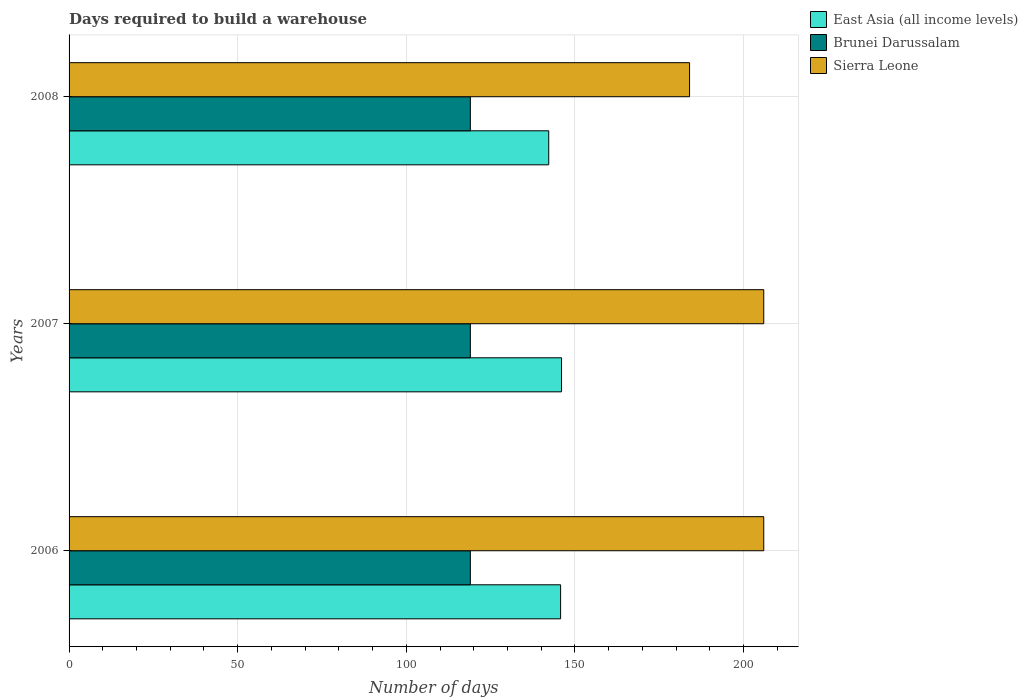How many different coloured bars are there?
Provide a succinct answer. 3. How many groups of bars are there?
Provide a succinct answer. 3. How many bars are there on the 2nd tick from the bottom?
Keep it short and to the point. 3. What is the label of the 2nd group of bars from the top?
Your answer should be compact. 2007. What is the days required to build a warehouse in in East Asia (all income levels) in 2006?
Keep it short and to the point. 145.76. Across all years, what is the maximum days required to build a warehouse in in East Asia (all income levels)?
Give a very brief answer. 146.04. Across all years, what is the minimum days required to build a warehouse in in Brunei Darussalam?
Provide a succinct answer. 119. What is the total days required to build a warehouse in in Sierra Leone in the graph?
Your response must be concise. 596. What is the difference between the days required to build a warehouse in in East Asia (all income levels) in 2006 and that in 2007?
Your answer should be compact. -0.28. What is the difference between the days required to build a warehouse in in Brunei Darussalam in 2006 and the days required to build a warehouse in in East Asia (all income levels) in 2008?
Your response must be concise. -23.24. What is the average days required to build a warehouse in in East Asia (all income levels) per year?
Keep it short and to the point. 144.68. In the year 2007, what is the difference between the days required to build a warehouse in in East Asia (all income levels) and days required to build a warehouse in in Brunei Darussalam?
Provide a short and direct response. 27.04. In how many years, is the days required to build a warehouse in in East Asia (all income levels) greater than 140 days?
Give a very brief answer. 3. What is the ratio of the days required to build a warehouse in in East Asia (all income levels) in 2006 to that in 2007?
Your answer should be very brief. 1. Is the days required to build a warehouse in in East Asia (all income levels) in 2006 less than that in 2007?
Ensure brevity in your answer.  Yes. Is the difference between the days required to build a warehouse in in East Asia (all income levels) in 2006 and 2008 greater than the difference between the days required to build a warehouse in in Brunei Darussalam in 2006 and 2008?
Your answer should be very brief. Yes. What is the difference between the highest and the lowest days required to build a warehouse in in Sierra Leone?
Your response must be concise. 22. Is the sum of the days required to build a warehouse in in Brunei Darussalam in 2006 and 2008 greater than the maximum days required to build a warehouse in in Sierra Leone across all years?
Keep it short and to the point. Yes. What does the 3rd bar from the top in 2006 represents?
Provide a short and direct response. East Asia (all income levels). What does the 2nd bar from the bottom in 2006 represents?
Make the answer very short. Brunei Darussalam. How many bars are there?
Provide a short and direct response. 9. Does the graph contain any zero values?
Provide a succinct answer. No. How many legend labels are there?
Your answer should be very brief. 3. How are the legend labels stacked?
Provide a succinct answer. Vertical. What is the title of the graph?
Make the answer very short. Days required to build a warehouse. Does "Afghanistan" appear as one of the legend labels in the graph?
Provide a succinct answer. No. What is the label or title of the X-axis?
Provide a short and direct response. Number of days. What is the Number of days in East Asia (all income levels) in 2006?
Ensure brevity in your answer.  145.76. What is the Number of days in Brunei Darussalam in 2006?
Offer a terse response. 119. What is the Number of days of Sierra Leone in 2006?
Your answer should be very brief. 206. What is the Number of days of East Asia (all income levels) in 2007?
Make the answer very short. 146.04. What is the Number of days in Brunei Darussalam in 2007?
Provide a succinct answer. 119. What is the Number of days of Sierra Leone in 2007?
Give a very brief answer. 206. What is the Number of days of East Asia (all income levels) in 2008?
Provide a short and direct response. 142.24. What is the Number of days in Brunei Darussalam in 2008?
Ensure brevity in your answer.  119. What is the Number of days in Sierra Leone in 2008?
Provide a succinct answer. 184. Across all years, what is the maximum Number of days in East Asia (all income levels)?
Provide a short and direct response. 146.04. Across all years, what is the maximum Number of days in Brunei Darussalam?
Your answer should be compact. 119. Across all years, what is the maximum Number of days in Sierra Leone?
Provide a short and direct response. 206. Across all years, what is the minimum Number of days in East Asia (all income levels)?
Keep it short and to the point. 142.24. Across all years, what is the minimum Number of days in Brunei Darussalam?
Ensure brevity in your answer.  119. Across all years, what is the minimum Number of days of Sierra Leone?
Your response must be concise. 184. What is the total Number of days of East Asia (all income levels) in the graph?
Ensure brevity in your answer.  434.04. What is the total Number of days in Brunei Darussalam in the graph?
Ensure brevity in your answer.  357. What is the total Number of days in Sierra Leone in the graph?
Provide a short and direct response. 596. What is the difference between the Number of days of East Asia (all income levels) in 2006 and that in 2007?
Provide a short and direct response. -0.28. What is the difference between the Number of days of Brunei Darussalam in 2006 and that in 2007?
Your response must be concise. 0. What is the difference between the Number of days of East Asia (all income levels) in 2006 and that in 2008?
Offer a very short reply. 3.52. What is the difference between the Number of days of Sierra Leone in 2006 and that in 2008?
Keep it short and to the point. 22. What is the difference between the Number of days of East Asia (all income levels) in 2007 and that in 2008?
Ensure brevity in your answer.  3.8. What is the difference between the Number of days in Sierra Leone in 2007 and that in 2008?
Provide a short and direct response. 22. What is the difference between the Number of days in East Asia (all income levels) in 2006 and the Number of days in Brunei Darussalam in 2007?
Keep it short and to the point. 26.76. What is the difference between the Number of days in East Asia (all income levels) in 2006 and the Number of days in Sierra Leone in 2007?
Ensure brevity in your answer.  -60.24. What is the difference between the Number of days of Brunei Darussalam in 2006 and the Number of days of Sierra Leone in 2007?
Offer a very short reply. -87. What is the difference between the Number of days of East Asia (all income levels) in 2006 and the Number of days of Brunei Darussalam in 2008?
Your answer should be compact. 26.76. What is the difference between the Number of days in East Asia (all income levels) in 2006 and the Number of days in Sierra Leone in 2008?
Your answer should be very brief. -38.24. What is the difference between the Number of days in Brunei Darussalam in 2006 and the Number of days in Sierra Leone in 2008?
Ensure brevity in your answer.  -65. What is the difference between the Number of days in East Asia (all income levels) in 2007 and the Number of days in Brunei Darussalam in 2008?
Offer a terse response. 27.04. What is the difference between the Number of days of East Asia (all income levels) in 2007 and the Number of days of Sierra Leone in 2008?
Offer a terse response. -37.96. What is the difference between the Number of days of Brunei Darussalam in 2007 and the Number of days of Sierra Leone in 2008?
Keep it short and to the point. -65. What is the average Number of days of East Asia (all income levels) per year?
Give a very brief answer. 144.68. What is the average Number of days of Brunei Darussalam per year?
Offer a terse response. 119. What is the average Number of days in Sierra Leone per year?
Provide a short and direct response. 198.67. In the year 2006, what is the difference between the Number of days of East Asia (all income levels) and Number of days of Brunei Darussalam?
Ensure brevity in your answer.  26.76. In the year 2006, what is the difference between the Number of days of East Asia (all income levels) and Number of days of Sierra Leone?
Your answer should be compact. -60.24. In the year 2006, what is the difference between the Number of days in Brunei Darussalam and Number of days in Sierra Leone?
Your answer should be very brief. -87. In the year 2007, what is the difference between the Number of days of East Asia (all income levels) and Number of days of Brunei Darussalam?
Ensure brevity in your answer.  27.04. In the year 2007, what is the difference between the Number of days of East Asia (all income levels) and Number of days of Sierra Leone?
Ensure brevity in your answer.  -59.96. In the year 2007, what is the difference between the Number of days of Brunei Darussalam and Number of days of Sierra Leone?
Offer a very short reply. -87. In the year 2008, what is the difference between the Number of days in East Asia (all income levels) and Number of days in Brunei Darussalam?
Offer a very short reply. 23.24. In the year 2008, what is the difference between the Number of days of East Asia (all income levels) and Number of days of Sierra Leone?
Your answer should be compact. -41.76. In the year 2008, what is the difference between the Number of days of Brunei Darussalam and Number of days of Sierra Leone?
Keep it short and to the point. -65. What is the ratio of the Number of days in East Asia (all income levels) in 2006 to that in 2008?
Ensure brevity in your answer.  1.02. What is the ratio of the Number of days in Sierra Leone in 2006 to that in 2008?
Your answer should be compact. 1.12. What is the ratio of the Number of days of East Asia (all income levels) in 2007 to that in 2008?
Offer a very short reply. 1.03. What is the ratio of the Number of days of Brunei Darussalam in 2007 to that in 2008?
Ensure brevity in your answer.  1. What is the ratio of the Number of days of Sierra Leone in 2007 to that in 2008?
Your response must be concise. 1.12. What is the difference between the highest and the second highest Number of days in East Asia (all income levels)?
Ensure brevity in your answer.  0.28. What is the difference between the highest and the second highest Number of days of Brunei Darussalam?
Provide a short and direct response. 0. What is the difference between the highest and the second highest Number of days of Sierra Leone?
Give a very brief answer. 0. What is the difference between the highest and the lowest Number of days of East Asia (all income levels)?
Your response must be concise. 3.8. What is the difference between the highest and the lowest Number of days of Brunei Darussalam?
Your response must be concise. 0. What is the difference between the highest and the lowest Number of days of Sierra Leone?
Provide a short and direct response. 22. 